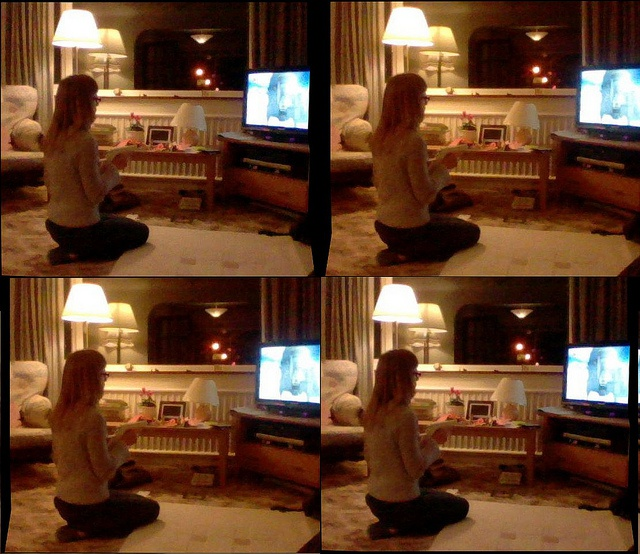Describe the objects in this image and their specific colors. I can see couch in black, tan, maroon, and brown tones, people in black, maroon, and brown tones, people in black, maroon, and brown tones, people in black, maroon, and brown tones, and people in black, maroon, and brown tones in this image. 